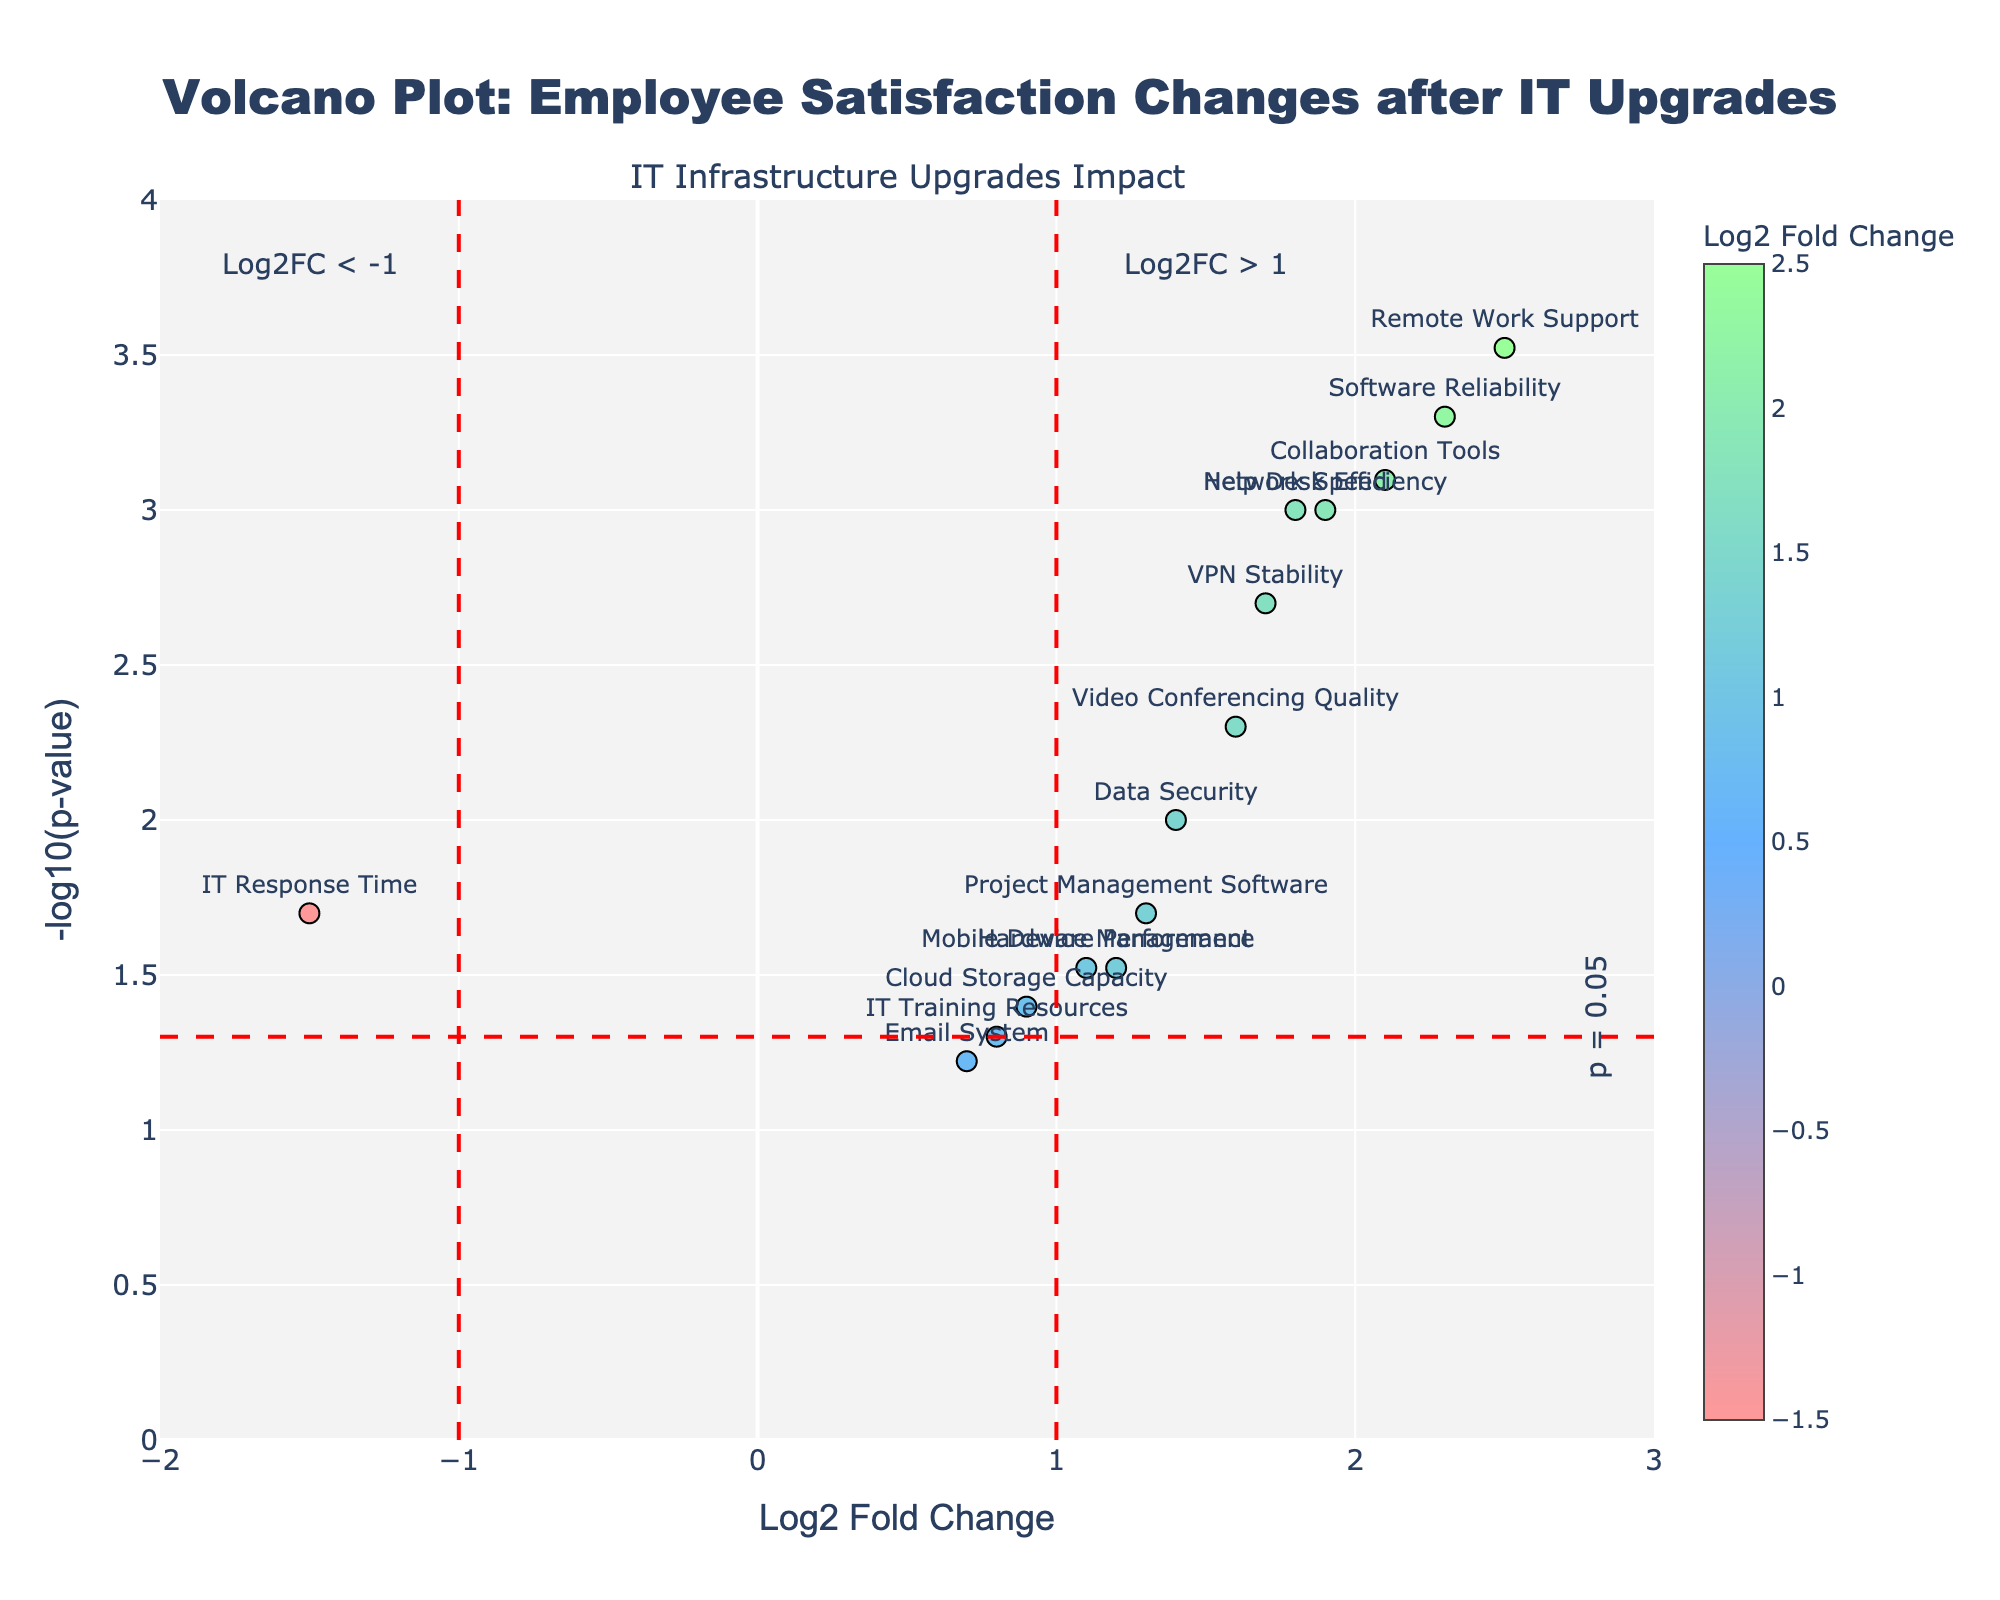What does the title of the plot indicate? The title of the plot is "Volcano Plot: Employee Satisfaction Changes After IT Upgrades". This indicates that the plot visualizes how employee satisfaction scores have changed following various IT infrastructure upgrades.
Answer: Employee Satisfaction Changes After IT Upgrades What do the x-axis and y-axis represent? The x-axis represents the Log2 Fold Change (logarithmic measure of change in satisfaction scores), and the y-axis represents the -log10(p-value) (inverse logarithmic measure of statistical significance).
Answer: Log2 Fold Change and -log10(p-value) Which IT upgrade factor shows the highest improvement in employee satisfaction scores? By looking at the x-axis ('Log2 Fold Change'), the factor "Remote Work Support" has the highest improvement with the largest positive Log2 Fold Change value.
Answer: Remote Work Support How many factors have a p-value less than 0.05? The threshold for a significant p-value is marked by a horizontal red dashed line at -log10(0.05). The factors above this line all have p-values less than 0.05. Counting these, there are 13 factors.
Answer: 13 Which factors show a significant decrease in employee satisfaction? A significant decrease in satisfaction is indicated by factors having Log2 Fold Change less than -1. The only factor in this range is "IT Response Time".
Answer: IT Response Time Which factor has the lowest statistical significance? The p-value is inversely related to the -log10(p-value), so the factor with the lowest point on the y-axis indicates the highest p-value, which is "Email System".
Answer: Email System What is the range of the Log2 Fold Change values? The x-axis limits can be determined by the range of points along this axis. The minimum Log2 Fold Change is approximately -1.5, and the maximum is approximately 2.5.
Answer: -1.5 to 2.5 Are there more factors with positive or negative Log2 Fold Change values? By visually assessing the distribution of points around the x-axis, more factors are to the right (positive values) compared to the left (negative values). Counting the factors confirms this.
Answer: Positive What is the Log2 Fold Change value for "Collaboration Tools"? "Collaboration Tools" is labeled on the plot and its x-coordinate represents the Log2 Fold Change value. It is approximately 2.1.
Answer: 2.1 Which IT upgrade factor had a noticeable but not statistically significant effect? Factors above the p = 0.05 line are statistically significant, those below it are not. "IT Training Resources" has a Log2 Fold Change of 0.8 and a p-value of 0.05, indicating a noticeable but not statistically significant effect.
Answer: IT Training Resources 